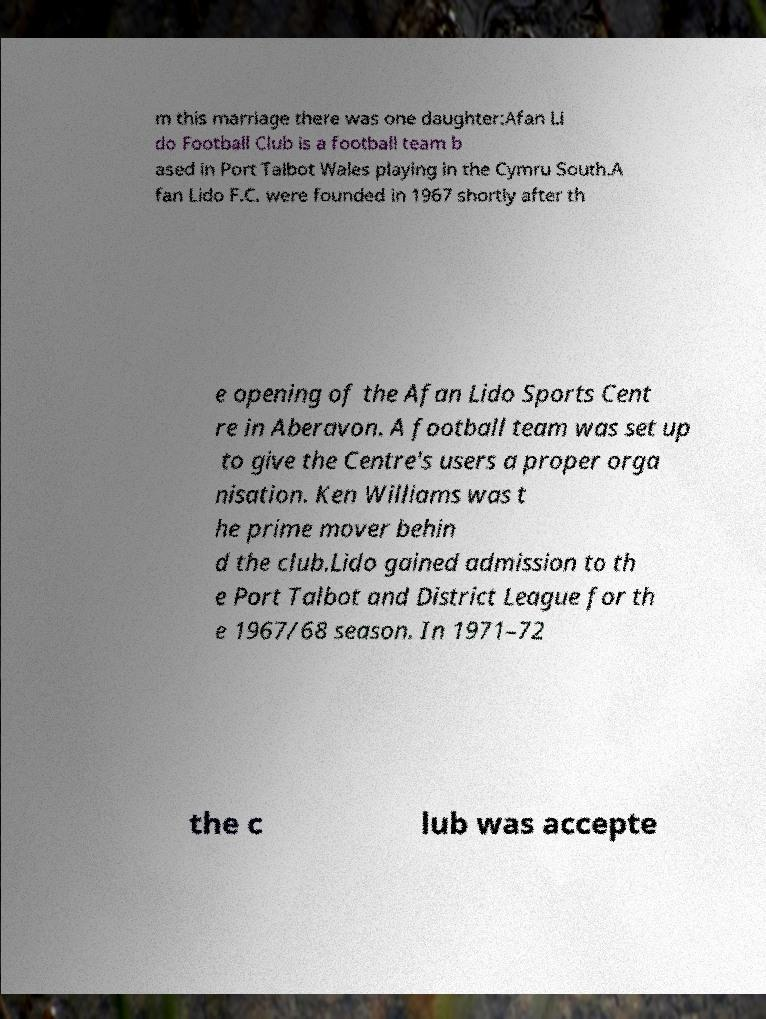Can you accurately transcribe the text from the provided image for me? m this marriage there was one daughter:Afan Li do Football Club is a football team b ased in Port Talbot Wales playing in the Cymru South.A fan Lido F.C. were founded in 1967 shortly after th e opening of the Afan Lido Sports Cent re in Aberavon. A football team was set up to give the Centre's users a proper orga nisation. Ken Williams was t he prime mover behin d the club.Lido gained admission to th e Port Talbot and District League for th e 1967/68 season. In 1971–72 the c lub was accepte 